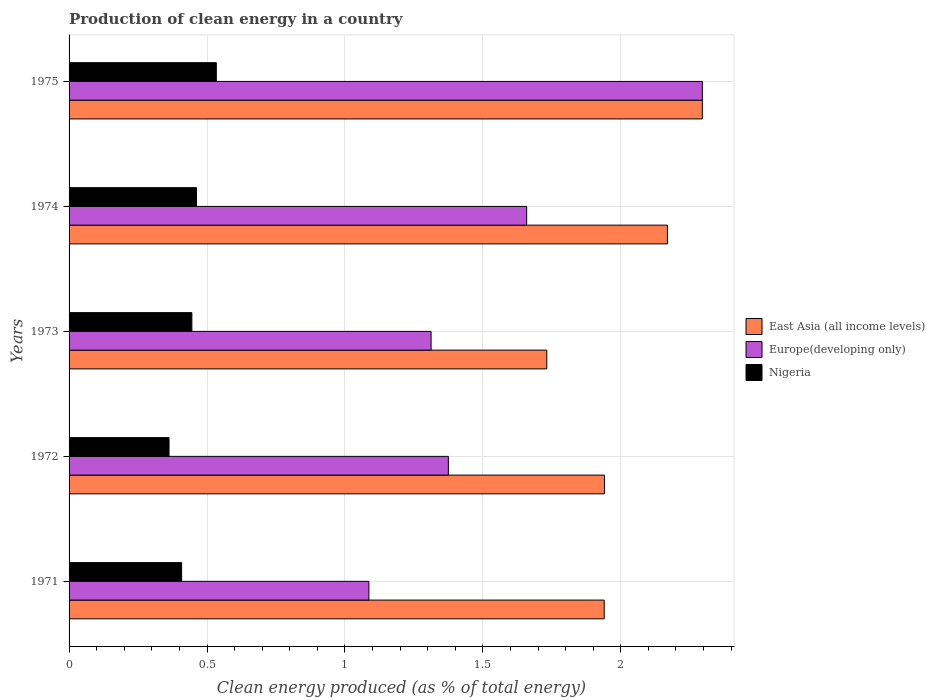How many different coloured bars are there?
Offer a terse response. 3. How many groups of bars are there?
Offer a terse response. 5. How many bars are there on the 1st tick from the top?
Provide a succinct answer. 3. How many bars are there on the 2nd tick from the bottom?
Give a very brief answer. 3. What is the percentage of clean energy produced in Europe(developing only) in 1973?
Offer a terse response. 1.31. Across all years, what is the maximum percentage of clean energy produced in Nigeria?
Your answer should be very brief. 0.53. Across all years, what is the minimum percentage of clean energy produced in East Asia (all income levels)?
Give a very brief answer. 1.73. In which year was the percentage of clean energy produced in Europe(developing only) maximum?
Your answer should be very brief. 1975. In which year was the percentage of clean energy produced in East Asia (all income levels) minimum?
Offer a very short reply. 1973. What is the total percentage of clean energy produced in East Asia (all income levels) in the graph?
Make the answer very short. 10.08. What is the difference between the percentage of clean energy produced in Europe(developing only) in 1974 and that in 1975?
Provide a succinct answer. -0.64. What is the difference between the percentage of clean energy produced in Nigeria in 1975 and the percentage of clean energy produced in East Asia (all income levels) in 1972?
Provide a short and direct response. -1.41. What is the average percentage of clean energy produced in East Asia (all income levels) per year?
Provide a succinct answer. 2.02. In the year 1975, what is the difference between the percentage of clean energy produced in Europe(developing only) and percentage of clean energy produced in East Asia (all income levels)?
Offer a terse response. 5.822379530995292e-5. What is the ratio of the percentage of clean energy produced in Europe(developing only) in 1971 to that in 1974?
Your answer should be compact. 0.66. What is the difference between the highest and the second highest percentage of clean energy produced in Europe(developing only)?
Your answer should be compact. 0.64. What is the difference between the highest and the lowest percentage of clean energy produced in East Asia (all income levels)?
Ensure brevity in your answer.  0.56. In how many years, is the percentage of clean energy produced in Nigeria greater than the average percentage of clean energy produced in Nigeria taken over all years?
Your answer should be very brief. 3. Is the sum of the percentage of clean energy produced in Nigeria in 1972 and 1974 greater than the maximum percentage of clean energy produced in Europe(developing only) across all years?
Keep it short and to the point. No. What does the 2nd bar from the top in 1971 represents?
Make the answer very short. Europe(developing only). What does the 3rd bar from the bottom in 1972 represents?
Give a very brief answer. Nigeria. Is it the case that in every year, the sum of the percentage of clean energy produced in East Asia (all income levels) and percentage of clean energy produced in Nigeria is greater than the percentage of clean energy produced in Europe(developing only)?
Offer a very short reply. Yes. How many bars are there?
Keep it short and to the point. 15. Are all the bars in the graph horizontal?
Ensure brevity in your answer.  Yes. How many years are there in the graph?
Provide a succinct answer. 5. What is the difference between two consecutive major ticks on the X-axis?
Give a very brief answer. 0.5. Does the graph contain grids?
Ensure brevity in your answer.  Yes. Where does the legend appear in the graph?
Your answer should be very brief. Center right. What is the title of the graph?
Make the answer very short. Production of clean energy in a country. Does "Low & middle income" appear as one of the legend labels in the graph?
Provide a short and direct response. No. What is the label or title of the X-axis?
Give a very brief answer. Clean energy produced (as % of total energy). What is the label or title of the Y-axis?
Offer a terse response. Years. What is the Clean energy produced (as % of total energy) of East Asia (all income levels) in 1971?
Keep it short and to the point. 1.94. What is the Clean energy produced (as % of total energy) in Europe(developing only) in 1971?
Provide a short and direct response. 1.09. What is the Clean energy produced (as % of total energy) in Nigeria in 1971?
Offer a terse response. 0.41. What is the Clean energy produced (as % of total energy) in East Asia (all income levels) in 1972?
Give a very brief answer. 1.94. What is the Clean energy produced (as % of total energy) in Europe(developing only) in 1972?
Keep it short and to the point. 1.37. What is the Clean energy produced (as % of total energy) in Nigeria in 1972?
Ensure brevity in your answer.  0.36. What is the Clean energy produced (as % of total energy) in East Asia (all income levels) in 1973?
Provide a short and direct response. 1.73. What is the Clean energy produced (as % of total energy) in Europe(developing only) in 1973?
Your response must be concise. 1.31. What is the Clean energy produced (as % of total energy) of Nigeria in 1973?
Offer a very short reply. 0.45. What is the Clean energy produced (as % of total energy) in East Asia (all income levels) in 1974?
Keep it short and to the point. 2.17. What is the Clean energy produced (as % of total energy) of Europe(developing only) in 1974?
Ensure brevity in your answer.  1.66. What is the Clean energy produced (as % of total energy) in Nigeria in 1974?
Provide a succinct answer. 0.46. What is the Clean energy produced (as % of total energy) of East Asia (all income levels) in 1975?
Make the answer very short. 2.3. What is the Clean energy produced (as % of total energy) of Europe(developing only) in 1975?
Offer a very short reply. 2.3. What is the Clean energy produced (as % of total energy) of Nigeria in 1975?
Give a very brief answer. 0.53. Across all years, what is the maximum Clean energy produced (as % of total energy) of East Asia (all income levels)?
Offer a terse response. 2.3. Across all years, what is the maximum Clean energy produced (as % of total energy) of Europe(developing only)?
Offer a very short reply. 2.3. Across all years, what is the maximum Clean energy produced (as % of total energy) of Nigeria?
Offer a very short reply. 0.53. Across all years, what is the minimum Clean energy produced (as % of total energy) in East Asia (all income levels)?
Give a very brief answer. 1.73. Across all years, what is the minimum Clean energy produced (as % of total energy) of Europe(developing only)?
Give a very brief answer. 1.09. Across all years, what is the minimum Clean energy produced (as % of total energy) of Nigeria?
Your answer should be compact. 0.36. What is the total Clean energy produced (as % of total energy) in East Asia (all income levels) in the graph?
Your response must be concise. 10.08. What is the total Clean energy produced (as % of total energy) of Europe(developing only) in the graph?
Make the answer very short. 7.73. What is the total Clean energy produced (as % of total energy) in Nigeria in the graph?
Ensure brevity in your answer.  2.21. What is the difference between the Clean energy produced (as % of total energy) of East Asia (all income levels) in 1971 and that in 1972?
Your answer should be compact. -0. What is the difference between the Clean energy produced (as % of total energy) in Europe(developing only) in 1971 and that in 1972?
Make the answer very short. -0.29. What is the difference between the Clean energy produced (as % of total energy) in Nigeria in 1971 and that in 1972?
Provide a short and direct response. 0.05. What is the difference between the Clean energy produced (as % of total energy) in East Asia (all income levels) in 1971 and that in 1973?
Provide a succinct answer. 0.21. What is the difference between the Clean energy produced (as % of total energy) of Europe(developing only) in 1971 and that in 1973?
Provide a short and direct response. -0.23. What is the difference between the Clean energy produced (as % of total energy) of Nigeria in 1971 and that in 1973?
Your answer should be compact. -0.04. What is the difference between the Clean energy produced (as % of total energy) in East Asia (all income levels) in 1971 and that in 1974?
Your response must be concise. -0.23. What is the difference between the Clean energy produced (as % of total energy) in Europe(developing only) in 1971 and that in 1974?
Your answer should be compact. -0.57. What is the difference between the Clean energy produced (as % of total energy) in Nigeria in 1971 and that in 1974?
Your response must be concise. -0.05. What is the difference between the Clean energy produced (as % of total energy) of East Asia (all income levels) in 1971 and that in 1975?
Your response must be concise. -0.36. What is the difference between the Clean energy produced (as % of total energy) of Europe(developing only) in 1971 and that in 1975?
Your response must be concise. -1.21. What is the difference between the Clean energy produced (as % of total energy) of Nigeria in 1971 and that in 1975?
Make the answer very short. -0.13. What is the difference between the Clean energy produced (as % of total energy) of East Asia (all income levels) in 1972 and that in 1973?
Offer a very short reply. 0.21. What is the difference between the Clean energy produced (as % of total energy) in Europe(developing only) in 1972 and that in 1973?
Your answer should be compact. 0.06. What is the difference between the Clean energy produced (as % of total energy) in Nigeria in 1972 and that in 1973?
Offer a very short reply. -0.08. What is the difference between the Clean energy produced (as % of total energy) in East Asia (all income levels) in 1972 and that in 1974?
Your response must be concise. -0.23. What is the difference between the Clean energy produced (as % of total energy) of Europe(developing only) in 1972 and that in 1974?
Your answer should be compact. -0.28. What is the difference between the Clean energy produced (as % of total energy) of Nigeria in 1972 and that in 1974?
Your answer should be very brief. -0.1. What is the difference between the Clean energy produced (as % of total energy) of East Asia (all income levels) in 1972 and that in 1975?
Give a very brief answer. -0.35. What is the difference between the Clean energy produced (as % of total energy) in Europe(developing only) in 1972 and that in 1975?
Keep it short and to the point. -0.92. What is the difference between the Clean energy produced (as % of total energy) of Nigeria in 1972 and that in 1975?
Your answer should be compact. -0.17. What is the difference between the Clean energy produced (as % of total energy) in East Asia (all income levels) in 1973 and that in 1974?
Give a very brief answer. -0.44. What is the difference between the Clean energy produced (as % of total energy) in Europe(developing only) in 1973 and that in 1974?
Keep it short and to the point. -0.35. What is the difference between the Clean energy produced (as % of total energy) of Nigeria in 1973 and that in 1974?
Your answer should be compact. -0.02. What is the difference between the Clean energy produced (as % of total energy) of East Asia (all income levels) in 1973 and that in 1975?
Ensure brevity in your answer.  -0.56. What is the difference between the Clean energy produced (as % of total energy) in Europe(developing only) in 1973 and that in 1975?
Your answer should be very brief. -0.98. What is the difference between the Clean energy produced (as % of total energy) in Nigeria in 1973 and that in 1975?
Offer a very short reply. -0.09. What is the difference between the Clean energy produced (as % of total energy) of East Asia (all income levels) in 1974 and that in 1975?
Provide a succinct answer. -0.13. What is the difference between the Clean energy produced (as % of total energy) in Europe(developing only) in 1974 and that in 1975?
Offer a very short reply. -0.64. What is the difference between the Clean energy produced (as % of total energy) of Nigeria in 1974 and that in 1975?
Provide a short and direct response. -0.07. What is the difference between the Clean energy produced (as % of total energy) of East Asia (all income levels) in 1971 and the Clean energy produced (as % of total energy) of Europe(developing only) in 1972?
Ensure brevity in your answer.  0.56. What is the difference between the Clean energy produced (as % of total energy) of East Asia (all income levels) in 1971 and the Clean energy produced (as % of total energy) of Nigeria in 1972?
Keep it short and to the point. 1.58. What is the difference between the Clean energy produced (as % of total energy) in Europe(developing only) in 1971 and the Clean energy produced (as % of total energy) in Nigeria in 1972?
Your answer should be compact. 0.72. What is the difference between the Clean energy produced (as % of total energy) of East Asia (all income levels) in 1971 and the Clean energy produced (as % of total energy) of Europe(developing only) in 1973?
Give a very brief answer. 0.63. What is the difference between the Clean energy produced (as % of total energy) of East Asia (all income levels) in 1971 and the Clean energy produced (as % of total energy) of Nigeria in 1973?
Your answer should be compact. 1.49. What is the difference between the Clean energy produced (as % of total energy) of Europe(developing only) in 1971 and the Clean energy produced (as % of total energy) of Nigeria in 1973?
Ensure brevity in your answer.  0.64. What is the difference between the Clean energy produced (as % of total energy) in East Asia (all income levels) in 1971 and the Clean energy produced (as % of total energy) in Europe(developing only) in 1974?
Provide a short and direct response. 0.28. What is the difference between the Clean energy produced (as % of total energy) in East Asia (all income levels) in 1971 and the Clean energy produced (as % of total energy) in Nigeria in 1974?
Your answer should be very brief. 1.48. What is the difference between the Clean energy produced (as % of total energy) of Europe(developing only) in 1971 and the Clean energy produced (as % of total energy) of Nigeria in 1974?
Ensure brevity in your answer.  0.62. What is the difference between the Clean energy produced (as % of total energy) in East Asia (all income levels) in 1971 and the Clean energy produced (as % of total energy) in Europe(developing only) in 1975?
Keep it short and to the point. -0.36. What is the difference between the Clean energy produced (as % of total energy) of East Asia (all income levels) in 1971 and the Clean energy produced (as % of total energy) of Nigeria in 1975?
Provide a short and direct response. 1.41. What is the difference between the Clean energy produced (as % of total energy) in Europe(developing only) in 1971 and the Clean energy produced (as % of total energy) in Nigeria in 1975?
Offer a terse response. 0.55. What is the difference between the Clean energy produced (as % of total energy) of East Asia (all income levels) in 1972 and the Clean energy produced (as % of total energy) of Europe(developing only) in 1973?
Your answer should be compact. 0.63. What is the difference between the Clean energy produced (as % of total energy) in East Asia (all income levels) in 1972 and the Clean energy produced (as % of total energy) in Nigeria in 1973?
Provide a short and direct response. 1.5. What is the difference between the Clean energy produced (as % of total energy) of Europe(developing only) in 1972 and the Clean energy produced (as % of total energy) of Nigeria in 1973?
Offer a very short reply. 0.93. What is the difference between the Clean energy produced (as % of total energy) in East Asia (all income levels) in 1972 and the Clean energy produced (as % of total energy) in Europe(developing only) in 1974?
Keep it short and to the point. 0.28. What is the difference between the Clean energy produced (as % of total energy) in East Asia (all income levels) in 1972 and the Clean energy produced (as % of total energy) in Nigeria in 1974?
Offer a terse response. 1.48. What is the difference between the Clean energy produced (as % of total energy) in Europe(developing only) in 1972 and the Clean energy produced (as % of total energy) in Nigeria in 1974?
Your response must be concise. 0.91. What is the difference between the Clean energy produced (as % of total energy) of East Asia (all income levels) in 1972 and the Clean energy produced (as % of total energy) of Europe(developing only) in 1975?
Your response must be concise. -0.35. What is the difference between the Clean energy produced (as % of total energy) of East Asia (all income levels) in 1972 and the Clean energy produced (as % of total energy) of Nigeria in 1975?
Provide a short and direct response. 1.41. What is the difference between the Clean energy produced (as % of total energy) of Europe(developing only) in 1972 and the Clean energy produced (as % of total energy) of Nigeria in 1975?
Offer a very short reply. 0.84. What is the difference between the Clean energy produced (as % of total energy) of East Asia (all income levels) in 1973 and the Clean energy produced (as % of total energy) of Europe(developing only) in 1974?
Offer a terse response. 0.07. What is the difference between the Clean energy produced (as % of total energy) in East Asia (all income levels) in 1973 and the Clean energy produced (as % of total energy) in Nigeria in 1974?
Keep it short and to the point. 1.27. What is the difference between the Clean energy produced (as % of total energy) in Europe(developing only) in 1973 and the Clean energy produced (as % of total energy) in Nigeria in 1974?
Provide a succinct answer. 0.85. What is the difference between the Clean energy produced (as % of total energy) in East Asia (all income levels) in 1973 and the Clean energy produced (as % of total energy) in Europe(developing only) in 1975?
Provide a succinct answer. -0.56. What is the difference between the Clean energy produced (as % of total energy) in East Asia (all income levels) in 1973 and the Clean energy produced (as % of total energy) in Nigeria in 1975?
Your response must be concise. 1.2. What is the difference between the Clean energy produced (as % of total energy) in Europe(developing only) in 1973 and the Clean energy produced (as % of total energy) in Nigeria in 1975?
Offer a very short reply. 0.78. What is the difference between the Clean energy produced (as % of total energy) in East Asia (all income levels) in 1974 and the Clean energy produced (as % of total energy) in Europe(developing only) in 1975?
Give a very brief answer. -0.13. What is the difference between the Clean energy produced (as % of total energy) in East Asia (all income levels) in 1974 and the Clean energy produced (as % of total energy) in Nigeria in 1975?
Offer a very short reply. 1.64. What is the difference between the Clean energy produced (as % of total energy) of Europe(developing only) in 1974 and the Clean energy produced (as % of total energy) of Nigeria in 1975?
Keep it short and to the point. 1.12. What is the average Clean energy produced (as % of total energy) of East Asia (all income levels) per year?
Offer a terse response. 2.02. What is the average Clean energy produced (as % of total energy) in Europe(developing only) per year?
Keep it short and to the point. 1.55. What is the average Clean energy produced (as % of total energy) in Nigeria per year?
Offer a very short reply. 0.44. In the year 1971, what is the difference between the Clean energy produced (as % of total energy) in East Asia (all income levels) and Clean energy produced (as % of total energy) in Europe(developing only)?
Make the answer very short. 0.85. In the year 1971, what is the difference between the Clean energy produced (as % of total energy) of East Asia (all income levels) and Clean energy produced (as % of total energy) of Nigeria?
Make the answer very short. 1.53. In the year 1971, what is the difference between the Clean energy produced (as % of total energy) of Europe(developing only) and Clean energy produced (as % of total energy) of Nigeria?
Ensure brevity in your answer.  0.68. In the year 1972, what is the difference between the Clean energy produced (as % of total energy) in East Asia (all income levels) and Clean energy produced (as % of total energy) in Europe(developing only)?
Keep it short and to the point. 0.57. In the year 1972, what is the difference between the Clean energy produced (as % of total energy) of East Asia (all income levels) and Clean energy produced (as % of total energy) of Nigeria?
Offer a very short reply. 1.58. In the year 1972, what is the difference between the Clean energy produced (as % of total energy) of Europe(developing only) and Clean energy produced (as % of total energy) of Nigeria?
Your answer should be compact. 1.01. In the year 1973, what is the difference between the Clean energy produced (as % of total energy) of East Asia (all income levels) and Clean energy produced (as % of total energy) of Europe(developing only)?
Ensure brevity in your answer.  0.42. In the year 1973, what is the difference between the Clean energy produced (as % of total energy) in East Asia (all income levels) and Clean energy produced (as % of total energy) in Nigeria?
Your answer should be compact. 1.29. In the year 1973, what is the difference between the Clean energy produced (as % of total energy) in Europe(developing only) and Clean energy produced (as % of total energy) in Nigeria?
Give a very brief answer. 0.87. In the year 1974, what is the difference between the Clean energy produced (as % of total energy) in East Asia (all income levels) and Clean energy produced (as % of total energy) in Europe(developing only)?
Provide a succinct answer. 0.51. In the year 1974, what is the difference between the Clean energy produced (as % of total energy) of East Asia (all income levels) and Clean energy produced (as % of total energy) of Nigeria?
Provide a succinct answer. 1.71. In the year 1974, what is the difference between the Clean energy produced (as % of total energy) of Europe(developing only) and Clean energy produced (as % of total energy) of Nigeria?
Provide a short and direct response. 1.2. In the year 1975, what is the difference between the Clean energy produced (as % of total energy) in East Asia (all income levels) and Clean energy produced (as % of total energy) in Europe(developing only)?
Offer a very short reply. -0. In the year 1975, what is the difference between the Clean energy produced (as % of total energy) in East Asia (all income levels) and Clean energy produced (as % of total energy) in Nigeria?
Make the answer very short. 1.76. In the year 1975, what is the difference between the Clean energy produced (as % of total energy) of Europe(developing only) and Clean energy produced (as % of total energy) of Nigeria?
Offer a terse response. 1.76. What is the ratio of the Clean energy produced (as % of total energy) in East Asia (all income levels) in 1971 to that in 1972?
Offer a very short reply. 1. What is the ratio of the Clean energy produced (as % of total energy) in Europe(developing only) in 1971 to that in 1972?
Ensure brevity in your answer.  0.79. What is the ratio of the Clean energy produced (as % of total energy) of Nigeria in 1971 to that in 1972?
Your answer should be very brief. 1.13. What is the ratio of the Clean energy produced (as % of total energy) in East Asia (all income levels) in 1971 to that in 1973?
Your answer should be compact. 1.12. What is the ratio of the Clean energy produced (as % of total energy) in Europe(developing only) in 1971 to that in 1973?
Offer a terse response. 0.83. What is the ratio of the Clean energy produced (as % of total energy) of Nigeria in 1971 to that in 1973?
Offer a very short reply. 0.92. What is the ratio of the Clean energy produced (as % of total energy) of East Asia (all income levels) in 1971 to that in 1974?
Your response must be concise. 0.89. What is the ratio of the Clean energy produced (as % of total energy) in Europe(developing only) in 1971 to that in 1974?
Ensure brevity in your answer.  0.66. What is the ratio of the Clean energy produced (as % of total energy) of Nigeria in 1971 to that in 1974?
Offer a very short reply. 0.88. What is the ratio of the Clean energy produced (as % of total energy) of East Asia (all income levels) in 1971 to that in 1975?
Provide a succinct answer. 0.85. What is the ratio of the Clean energy produced (as % of total energy) of Europe(developing only) in 1971 to that in 1975?
Make the answer very short. 0.47. What is the ratio of the Clean energy produced (as % of total energy) in Nigeria in 1971 to that in 1975?
Your answer should be very brief. 0.76. What is the ratio of the Clean energy produced (as % of total energy) in East Asia (all income levels) in 1972 to that in 1973?
Make the answer very short. 1.12. What is the ratio of the Clean energy produced (as % of total energy) in Europe(developing only) in 1972 to that in 1973?
Offer a very short reply. 1.05. What is the ratio of the Clean energy produced (as % of total energy) in Nigeria in 1972 to that in 1973?
Give a very brief answer. 0.81. What is the ratio of the Clean energy produced (as % of total energy) in East Asia (all income levels) in 1972 to that in 1974?
Make the answer very short. 0.89. What is the ratio of the Clean energy produced (as % of total energy) of Europe(developing only) in 1972 to that in 1974?
Offer a very short reply. 0.83. What is the ratio of the Clean energy produced (as % of total energy) in Nigeria in 1972 to that in 1974?
Offer a terse response. 0.78. What is the ratio of the Clean energy produced (as % of total energy) of East Asia (all income levels) in 1972 to that in 1975?
Offer a terse response. 0.85. What is the ratio of the Clean energy produced (as % of total energy) of Europe(developing only) in 1972 to that in 1975?
Offer a terse response. 0.6. What is the ratio of the Clean energy produced (as % of total energy) of Nigeria in 1972 to that in 1975?
Offer a very short reply. 0.68. What is the ratio of the Clean energy produced (as % of total energy) in East Asia (all income levels) in 1973 to that in 1974?
Your response must be concise. 0.8. What is the ratio of the Clean energy produced (as % of total energy) in Europe(developing only) in 1973 to that in 1974?
Provide a succinct answer. 0.79. What is the ratio of the Clean energy produced (as % of total energy) of Nigeria in 1973 to that in 1974?
Provide a short and direct response. 0.96. What is the ratio of the Clean energy produced (as % of total energy) in East Asia (all income levels) in 1973 to that in 1975?
Your answer should be compact. 0.75. What is the ratio of the Clean energy produced (as % of total energy) in Europe(developing only) in 1973 to that in 1975?
Your answer should be compact. 0.57. What is the ratio of the Clean energy produced (as % of total energy) in Nigeria in 1973 to that in 1975?
Give a very brief answer. 0.83. What is the ratio of the Clean energy produced (as % of total energy) of East Asia (all income levels) in 1974 to that in 1975?
Your response must be concise. 0.94. What is the ratio of the Clean energy produced (as % of total energy) in Europe(developing only) in 1974 to that in 1975?
Provide a succinct answer. 0.72. What is the ratio of the Clean energy produced (as % of total energy) of Nigeria in 1974 to that in 1975?
Your answer should be very brief. 0.87. What is the difference between the highest and the second highest Clean energy produced (as % of total energy) of East Asia (all income levels)?
Offer a very short reply. 0.13. What is the difference between the highest and the second highest Clean energy produced (as % of total energy) in Europe(developing only)?
Give a very brief answer. 0.64. What is the difference between the highest and the second highest Clean energy produced (as % of total energy) of Nigeria?
Offer a terse response. 0.07. What is the difference between the highest and the lowest Clean energy produced (as % of total energy) of East Asia (all income levels)?
Offer a very short reply. 0.56. What is the difference between the highest and the lowest Clean energy produced (as % of total energy) in Europe(developing only)?
Ensure brevity in your answer.  1.21. What is the difference between the highest and the lowest Clean energy produced (as % of total energy) of Nigeria?
Offer a terse response. 0.17. 